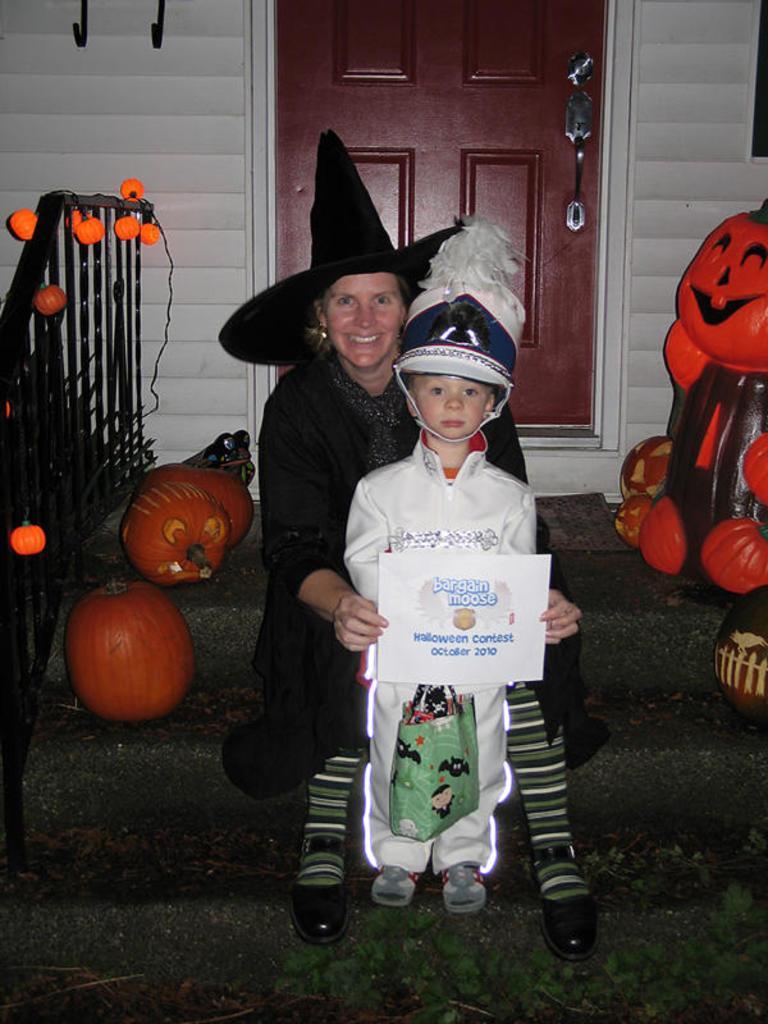Please provide a concise description of this image. There are steps. On the steps there is a lady wearing hat and holding a poster is sitting. Also there is a boy wearing helmet and holding a packet is standing. On the steps there are pumpkins. In the back there is a wall. Also there is a door. There is a railing with lights. And there are some decorations. 